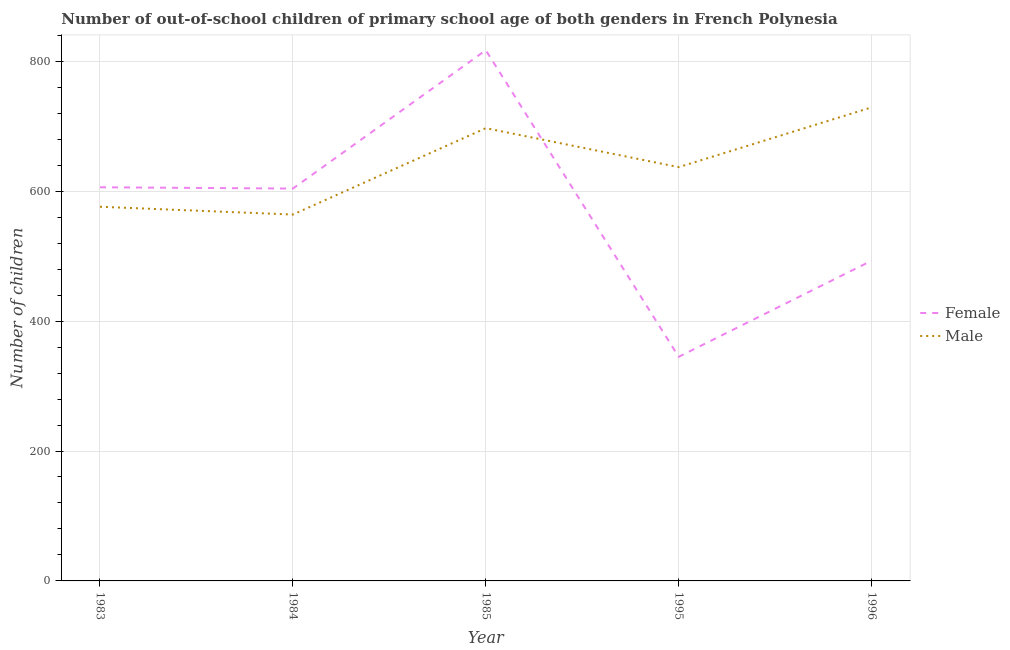Does the line corresponding to number of female out-of-school students intersect with the line corresponding to number of male out-of-school students?
Provide a short and direct response. Yes. What is the number of female out-of-school students in 1985?
Keep it short and to the point. 817. Across all years, what is the maximum number of female out-of-school students?
Give a very brief answer. 817. Across all years, what is the minimum number of male out-of-school students?
Provide a succinct answer. 564. In which year was the number of male out-of-school students minimum?
Provide a short and direct response. 1984. What is the total number of male out-of-school students in the graph?
Provide a short and direct response. 3203. What is the difference between the number of male out-of-school students in 1984 and that in 1985?
Offer a very short reply. -133. What is the difference between the number of female out-of-school students in 1984 and the number of male out-of-school students in 1995?
Keep it short and to the point. -33. What is the average number of female out-of-school students per year?
Offer a very short reply. 573. In the year 1983, what is the difference between the number of male out-of-school students and number of female out-of-school students?
Offer a terse response. -30. In how many years, is the number of female out-of-school students greater than 80?
Your answer should be very brief. 5. What is the ratio of the number of male out-of-school students in 1984 to that in 1996?
Provide a short and direct response. 0.77. What is the difference between the highest and the second highest number of female out-of-school students?
Give a very brief answer. 211. What is the difference between the highest and the lowest number of male out-of-school students?
Provide a short and direct response. 165. Is the number of female out-of-school students strictly less than the number of male out-of-school students over the years?
Ensure brevity in your answer.  No. How many lines are there?
Provide a short and direct response. 2. Does the graph contain any zero values?
Offer a terse response. No. Where does the legend appear in the graph?
Offer a very short reply. Center right. What is the title of the graph?
Your response must be concise. Number of out-of-school children of primary school age of both genders in French Polynesia. Does "Export" appear as one of the legend labels in the graph?
Keep it short and to the point. No. What is the label or title of the Y-axis?
Provide a short and direct response. Number of children. What is the Number of children of Female in 1983?
Your answer should be very brief. 606. What is the Number of children in Male in 1983?
Provide a succinct answer. 576. What is the Number of children of Female in 1984?
Keep it short and to the point. 604. What is the Number of children in Male in 1984?
Your response must be concise. 564. What is the Number of children of Female in 1985?
Your answer should be very brief. 817. What is the Number of children of Male in 1985?
Offer a very short reply. 697. What is the Number of children in Female in 1995?
Offer a very short reply. 345. What is the Number of children of Male in 1995?
Provide a succinct answer. 637. What is the Number of children of Female in 1996?
Give a very brief answer. 493. What is the Number of children in Male in 1996?
Keep it short and to the point. 729. Across all years, what is the maximum Number of children of Female?
Offer a terse response. 817. Across all years, what is the maximum Number of children in Male?
Ensure brevity in your answer.  729. Across all years, what is the minimum Number of children in Female?
Provide a succinct answer. 345. Across all years, what is the minimum Number of children of Male?
Your answer should be compact. 564. What is the total Number of children in Female in the graph?
Your response must be concise. 2865. What is the total Number of children in Male in the graph?
Provide a succinct answer. 3203. What is the difference between the Number of children of Female in 1983 and that in 1985?
Ensure brevity in your answer.  -211. What is the difference between the Number of children of Male in 1983 and that in 1985?
Provide a short and direct response. -121. What is the difference between the Number of children in Female in 1983 and that in 1995?
Provide a short and direct response. 261. What is the difference between the Number of children of Male in 1983 and that in 1995?
Keep it short and to the point. -61. What is the difference between the Number of children in Female in 1983 and that in 1996?
Your response must be concise. 113. What is the difference between the Number of children of Male in 1983 and that in 1996?
Make the answer very short. -153. What is the difference between the Number of children in Female in 1984 and that in 1985?
Provide a short and direct response. -213. What is the difference between the Number of children of Male in 1984 and that in 1985?
Ensure brevity in your answer.  -133. What is the difference between the Number of children in Female in 1984 and that in 1995?
Ensure brevity in your answer.  259. What is the difference between the Number of children in Male in 1984 and that in 1995?
Make the answer very short. -73. What is the difference between the Number of children in Female in 1984 and that in 1996?
Your answer should be compact. 111. What is the difference between the Number of children in Male in 1984 and that in 1996?
Provide a succinct answer. -165. What is the difference between the Number of children of Female in 1985 and that in 1995?
Give a very brief answer. 472. What is the difference between the Number of children of Male in 1985 and that in 1995?
Keep it short and to the point. 60. What is the difference between the Number of children of Female in 1985 and that in 1996?
Your response must be concise. 324. What is the difference between the Number of children of Male in 1985 and that in 1996?
Provide a short and direct response. -32. What is the difference between the Number of children in Female in 1995 and that in 1996?
Offer a very short reply. -148. What is the difference between the Number of children of Male in 1995 and that in 1996?
Ensure brevity in your answer.  -92. What is the difference between the Number of children in Female in 1983 and the Number of children in Male in 1984?
Offer a very short reply. 42. What is the difference between the Number of children of Female in 1983 and the Number of children of Male in 1985?
Make the answer very short. -91. What is the difference between the Number of children in Female in 1983 and the Number of children in Male in 1995?
Your response must be concise. -31. What is the difference between the Number of children of Female in 1983 and the Number of children of Male in 1996?
Offer a very short reply. -123. What is the difference between the Number of children of Female in 1984 and the Number of children of Male in 1985?
Offer a very short reply. -93. What is the difference between the Number of children in Female in 1984 and the Number of children in Male in 1995?
Provide a short and direct response. -33. What is the difference between the Number of children in Female in 1984 and the Number of children in Male in 1996?
Provide a short and direct response. -125. What is the difference between the Number of children of Female in 1985 and the Number of children of Male in 1995?
Offer a very short reply. 180. What is the difference between the Number of children in Female in 1995 and the Number of children in Male in 1996?
Your answer should be compact. -384. What is the average Number of children of Female per year?
Provide a short and direct response. 573. What is the average Number of children of Male per year?
Your answer should be very brief. 640.6. In the year 1985, what is the difference between the Number of children in Female and Number of children in Male?
Keep it short and to the point. 120. In the year 1995, what is the difference between the Number of children in Female and Number of children in Male?
Your answer should be very brief. -292. In the year 1996, what is the difference between the Number of children of Female and Number of children of Male?
Provide a succinct answer. -236. What is the ratio of the Number of children in Female in 1983 to that in 1984?
Your answer should be compact. 1. What is the ratio of the Number of children of Male in 1983 to that in 1984?
Offer a very short reply. 1.02. What is the ratio of the Number of children of Female in 1983 to that in 1985?
Your response must be concise. 0.74. What is the ratio of the Number of children in Male in 1983 to that in 1985?
Your answer should be very brief. 0.83. What is the ratio of the Number of children in Female in 1983 to that in 1995?
Keep it short and to the point. 1.76. What is the ratio of the Number of children of Male in 1983 to that in 1995?
Make the answer very short. 0.9. What is the ratio of the Number of children in Female in 1983 to that in 1996?
Keep it short and to the point. 1.23. What is the ratio of the Number of children in Male in 1983 to that in 1996?
Offer a very short reply. 0.79. What is the ratio of the Number of children in Female in 1984 to that in 1985?
Your answer should be compact. 0.74. What is the ratio of the Number of children of Male in 1984 to that in 1985?
Your answer should be compact. 0.81. What is the ratio of the Number of children of Female in 1984 to that in 1995?
Offer a very short reply. 1.75. What is the ratio of the Number of children of Male in 1984 to that in 1995?
Keep it short and to the point. 0.89. What is the ratio of the Number of children of Female in 1984 to that in 1996?
Keep it short and to the point. 1.23. What is the ratio of the Number of children of Male in 1984 to that in 1996?
Provide a short and direct response. 0.77. What is the ratio of the Number of children in Female in 1985 to that in 1995?
Your answer should be very brief. 2.37. What is the ratio of the Number of children in Male in 1985 to that in 1995?
Offer a very short reply. 1.09. What is the ratio of the Number of children of Female in 1985 to that in 1996?
Give a very brief answer. 1.66. What is the ratio of the Number of children in Male in 1985 to that in 1996?
Your response must be concise. 0.96. What is the ratio of the Number of children of Female in 1995 to that in 1996?
Your response must be concise. 0.7. What is the ratio of the Number of children in Male in 1995 to that in 1996?
Your answer should be very brief. 0.87. What is the difference between the highest and the second highest Number of children of Female?
Your answer should be compact. 211. What is the difference between the highest and the lowest Number of children of Female?
Ensure brevity in your answer.  472. What is the difference between the highest and the lowest Number of children of Male?
Your response must be concise. 165. 